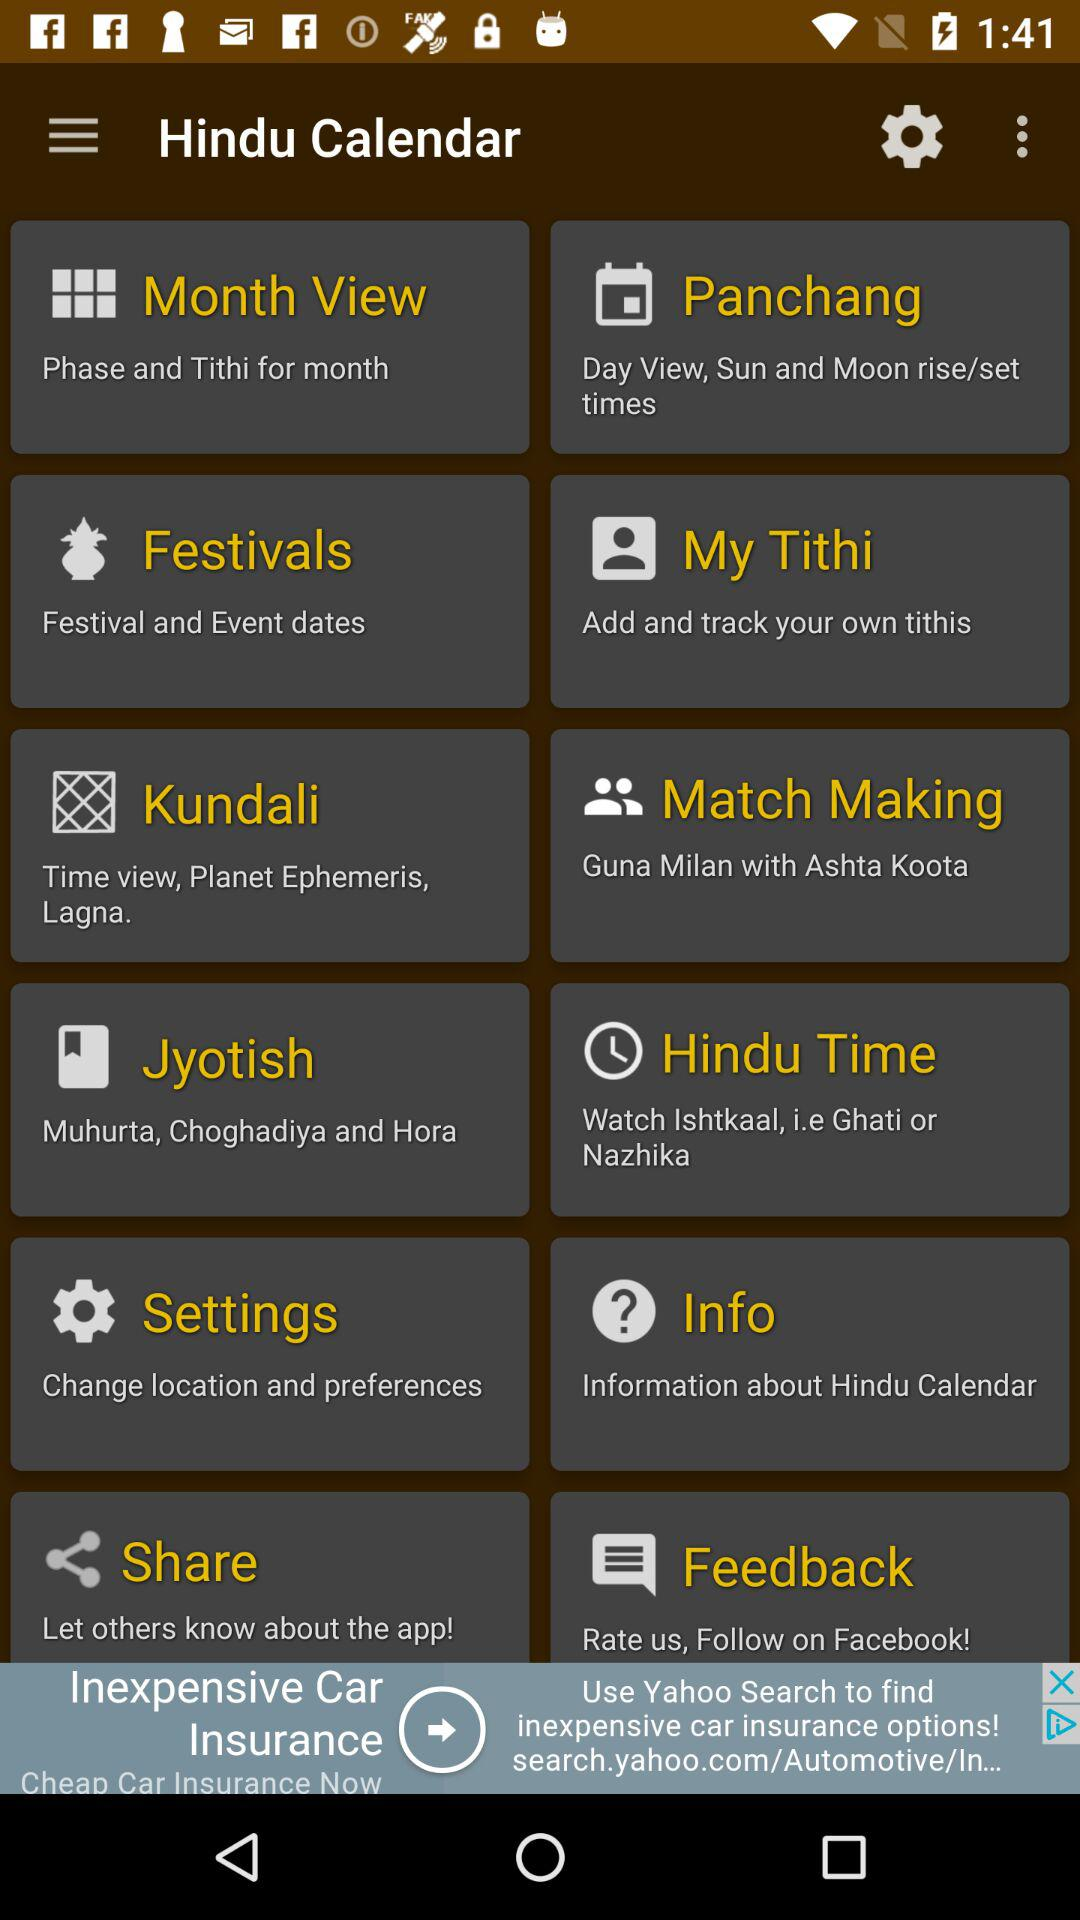What is the name of the application? The name of the application is "Hindu Calendar". 